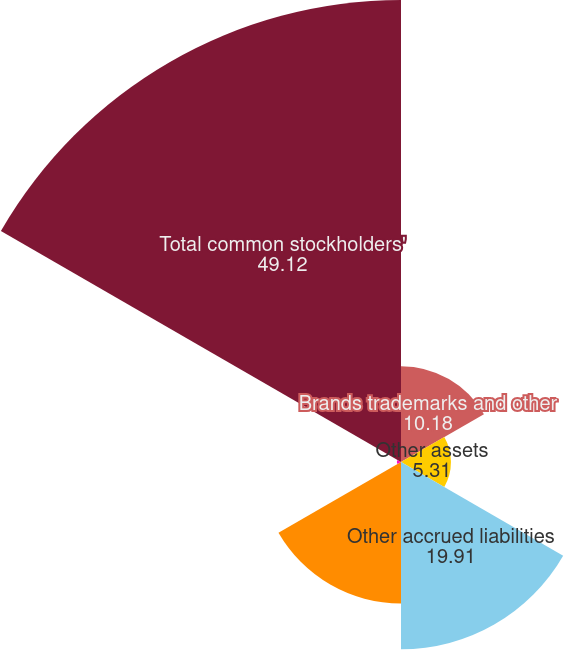Convert chart to OTSL. <chart><loc_0><loc_0><loc_500><loc_500><pie_chart><fcel>Brands trademarks and other<fcel>Other assets<fcel>Other accrued liabilities<fcel>Other noncurrent liabilities<fcel>Accumulated other<fcel>Total common stockholders'<nl><fcel>10.18%<fcel>5.31%<fcel>19.91%<fcel>15.04%<fcel>0.44%<fcel>49.12%<nl></chart> 